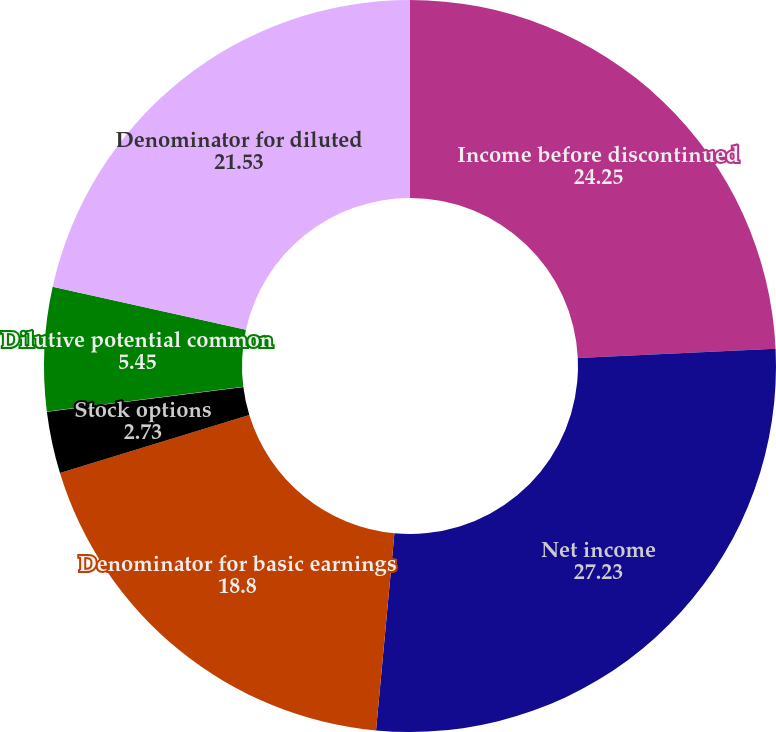Convert chart to OTSL. <chart><loc_0><loc_0><loc_500><loc_500><pie_chart><fcel>Income before discontinued<fcel>Net income<fcel>Denominator for basic earnings<fcel>Stock options<fcel>Time vesting restricted stock<fcel>Dilutive potential common<fcel>Denominator for diluted<nl><fcel>24.25%<fcel>27.23%<fcel>18.8%<fcel>2.73%<fcel>0.01%<fcel>5.45%<fcel>21.53%<nl></chart> 